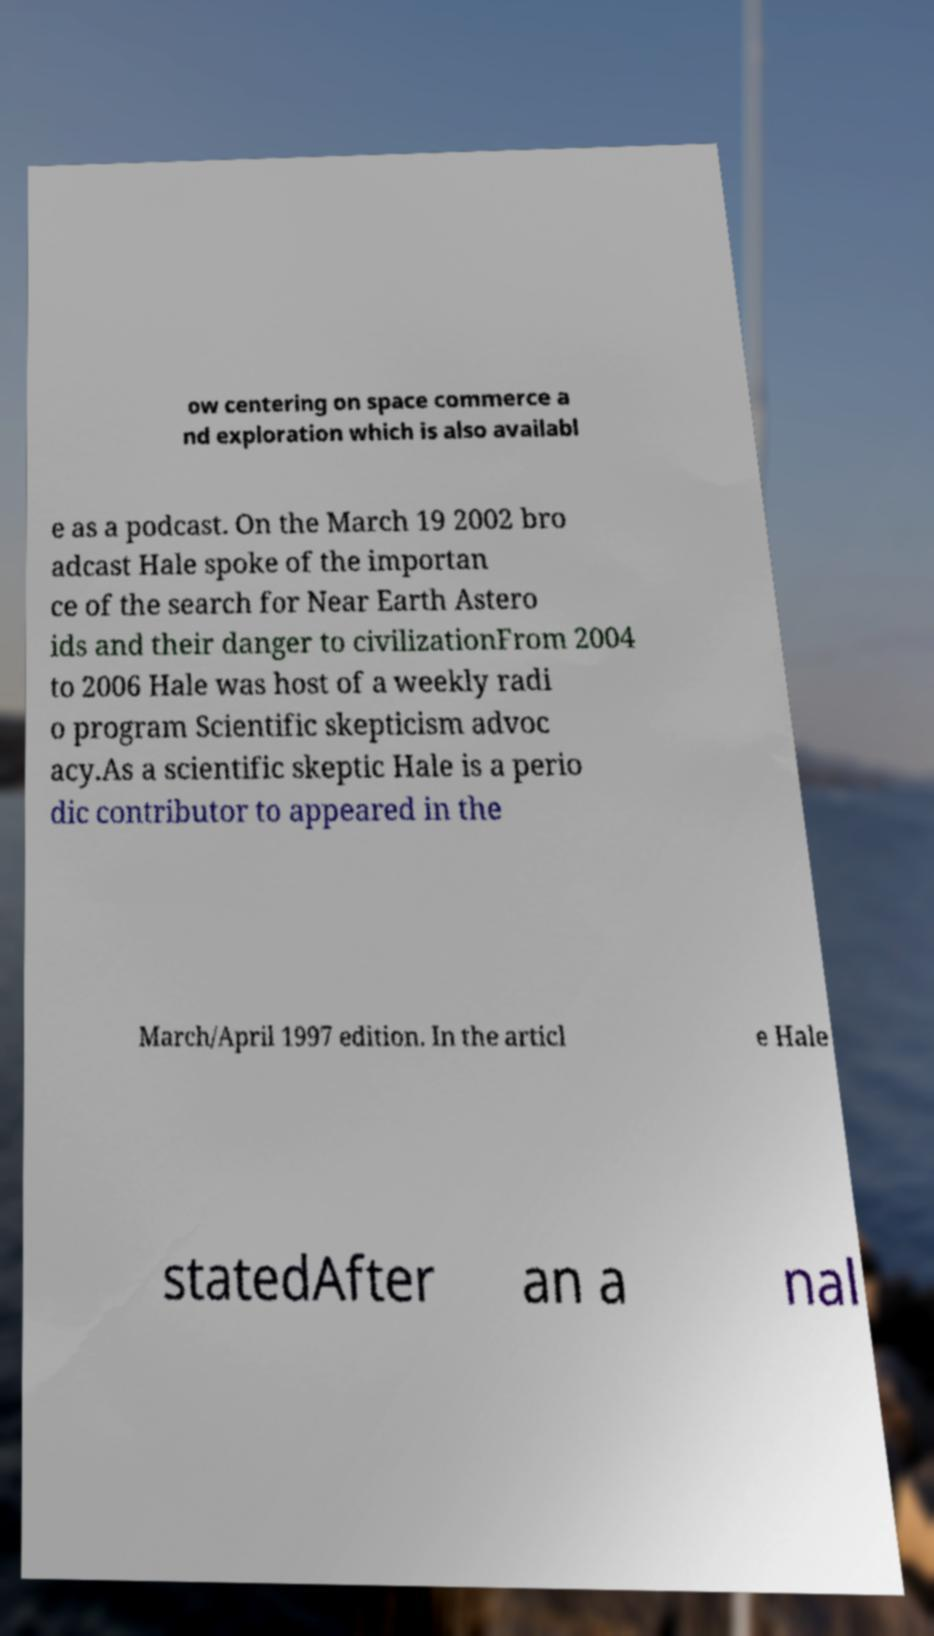Please read and relay the text visible in this image. What does it say? ow centering on space commerce a nd exploration which is also availabl e as a podcast. On the March 19 2002 bro adcast Hale spoke of the importan ce of the search for Near Earth Astero ids and their danger to civilizationFrom 2004 to 2006 Hale was host of a weekly radi o program Scientific skepticism advoc acy.As a scientific skeptic Hale is a perio dic contributor to appeared in the March/April 1997 edition. In the articl e Hale statedAfter an a nal 